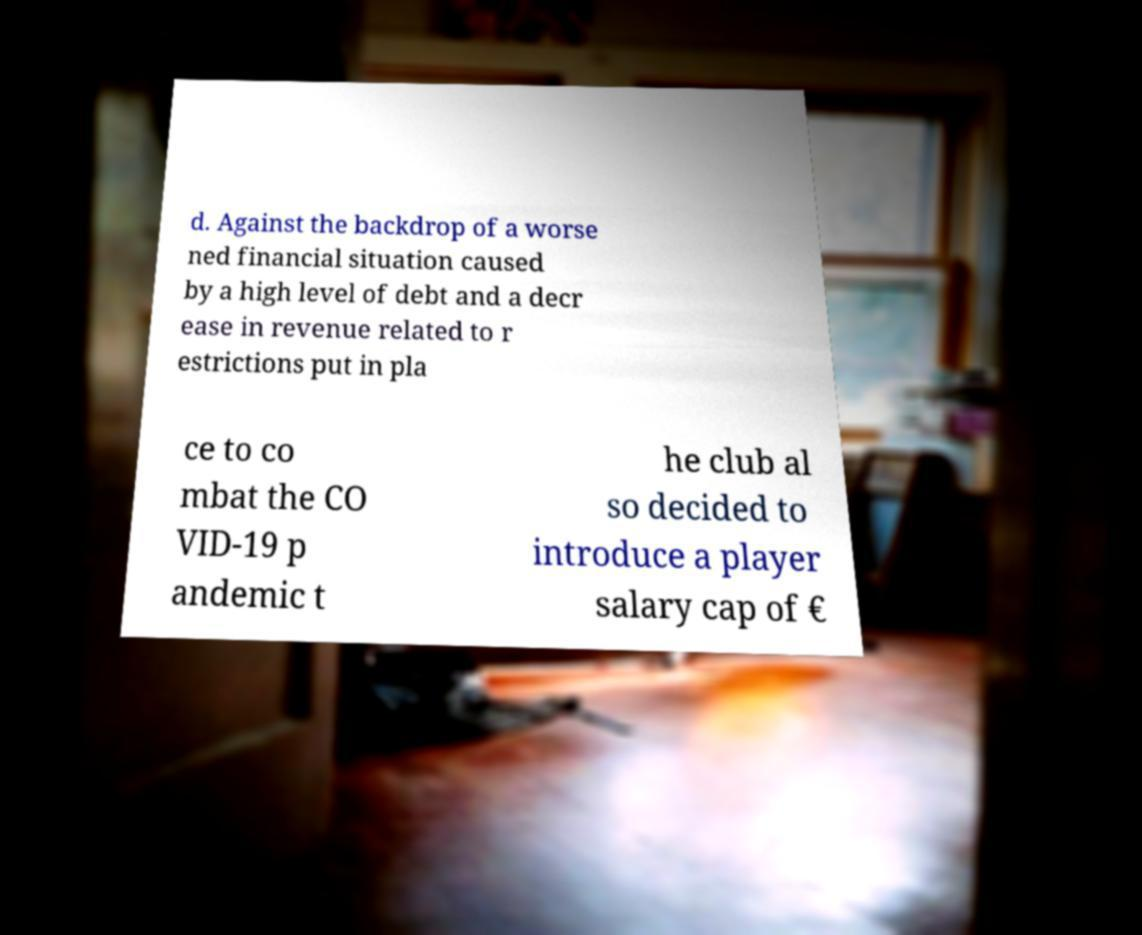I need the written content from this picture converted into text. Can you do that? d. Against the backdrop of a worse ned financial situation caused by a high level of debt and a decr ease in revenue related to r estrictions put in pla ce to co mbat the CO VID-19 p andemic t he club al so decided to introduce a player salary cap of € 